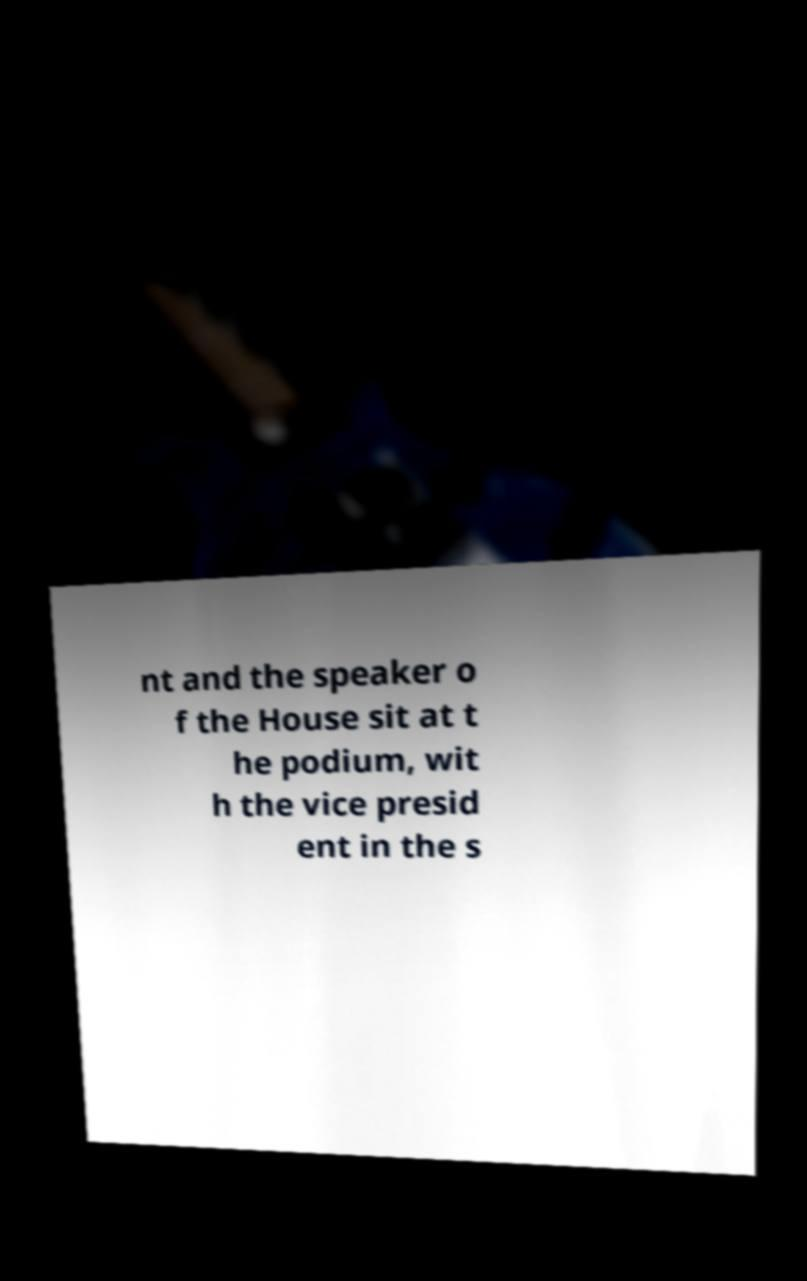Can you accurately transcribe the text from the provided image for me? nt and the speaker o f the House sit at t he podium, wit h the vice presid ent in the s 